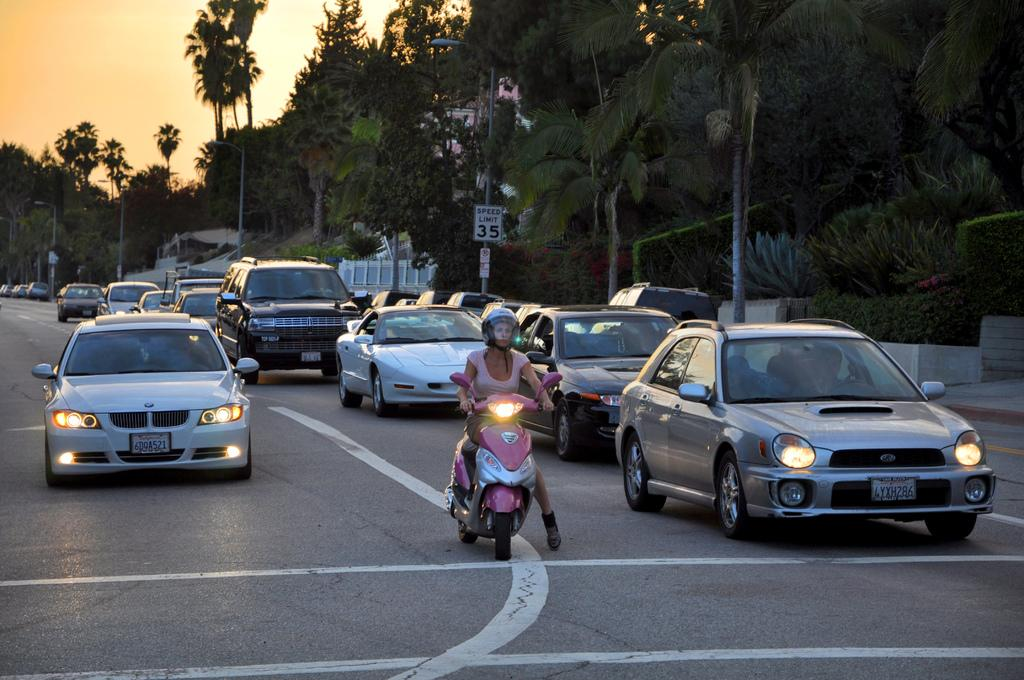What can be seen on the road in the image? There are vehicles on the road in the image. What type of natural elements are visible in the image? There are trees visible in the image. What structures can be seen in the image? There are poles and boards in the image. What is visible in the background of the image? The sky is visible in the image. What type of poles are present in the image? There are light poles in the image. What type of learning can be observed taking place under the shade of the trees in the image? There is no learning or shade of trees visible in the image. How does the comparison between the vehicles and the trees in the image help us understand the environment? There is no comparison being made between the vehicles and the trees in the image. 